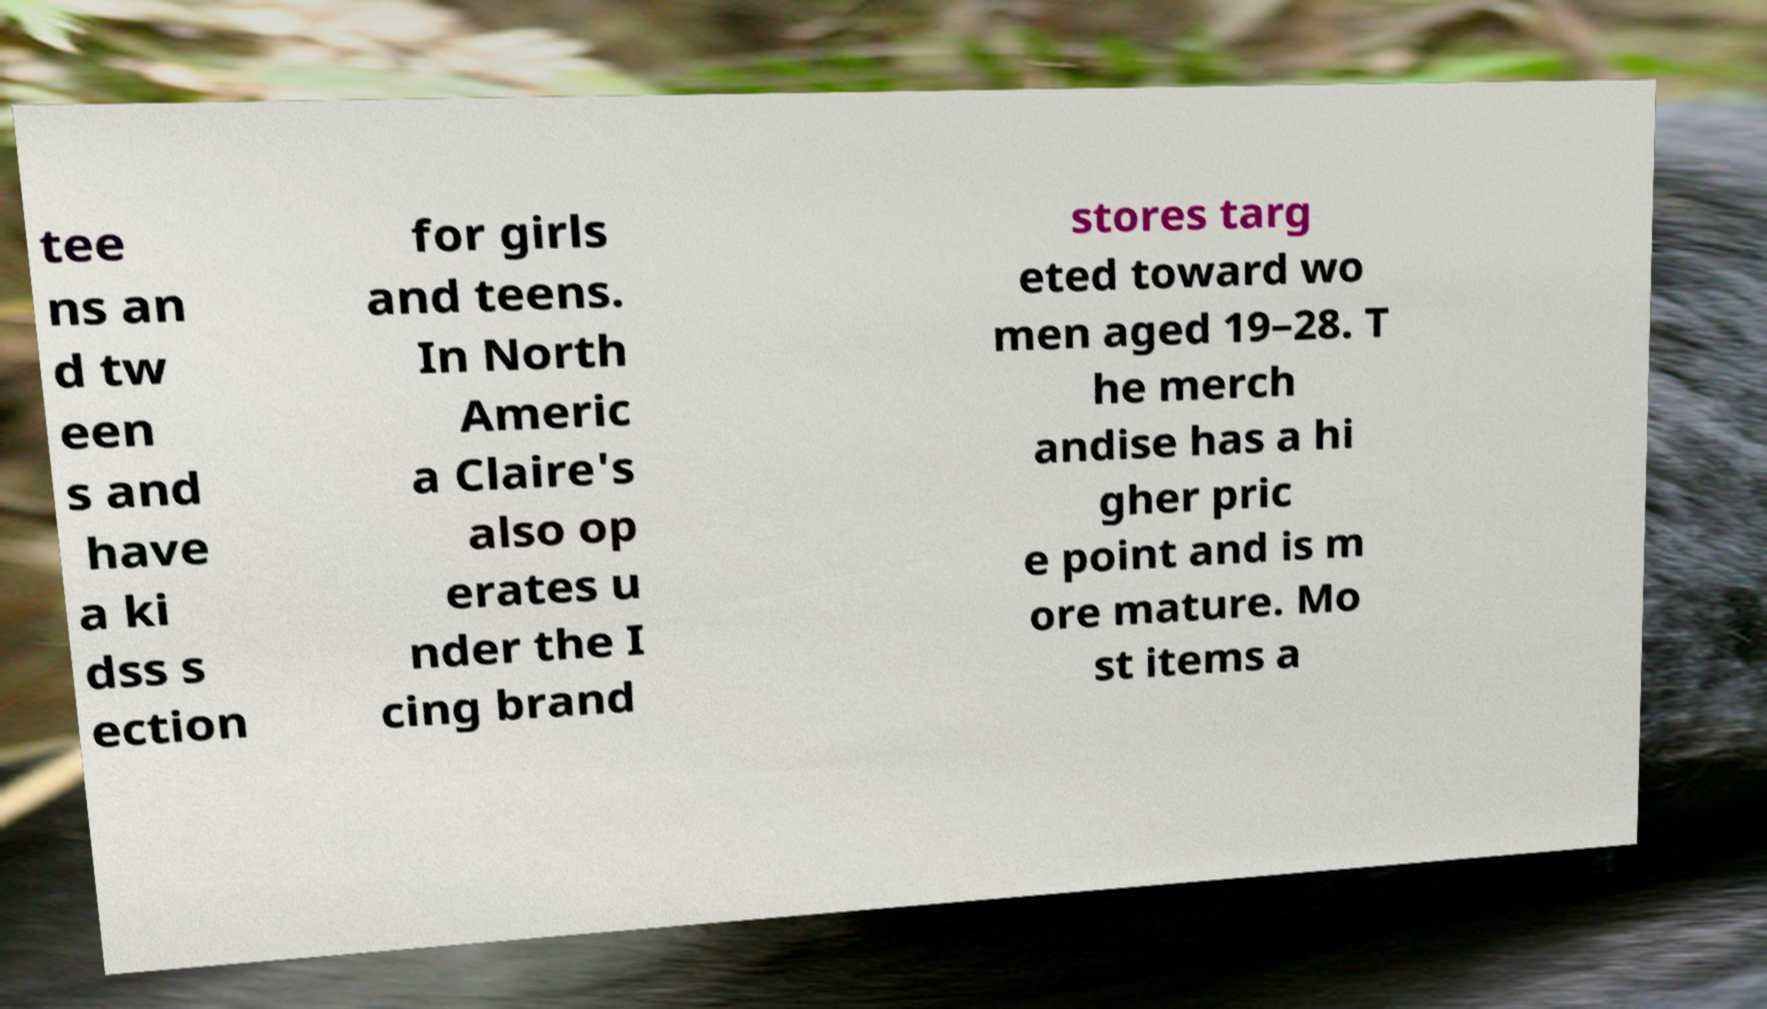Can you read and provide the text displayed in the image?This photo seems to have some interesting text. Can you extract and type it out for me? tee ns an d tw een s and have a ki dss s ection for girls and teens. In North Americ a Claire's also op erates u nder the I cing brand stores targ eted toward wo men aged 19–28. T he merch andise has a hi gher pric e point and is m ore mature. Mo st items a 